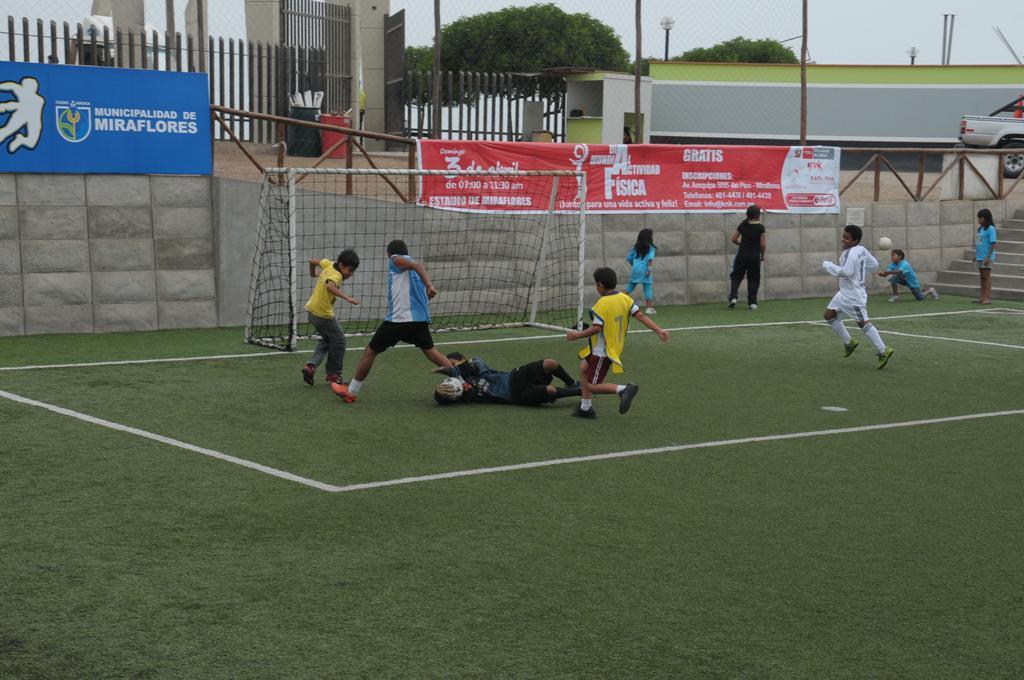Please provide a concise description of this image. In the image we can see there are kids who are playing in the playground and playing football and at the back there is goal net and there are lot of trees. 